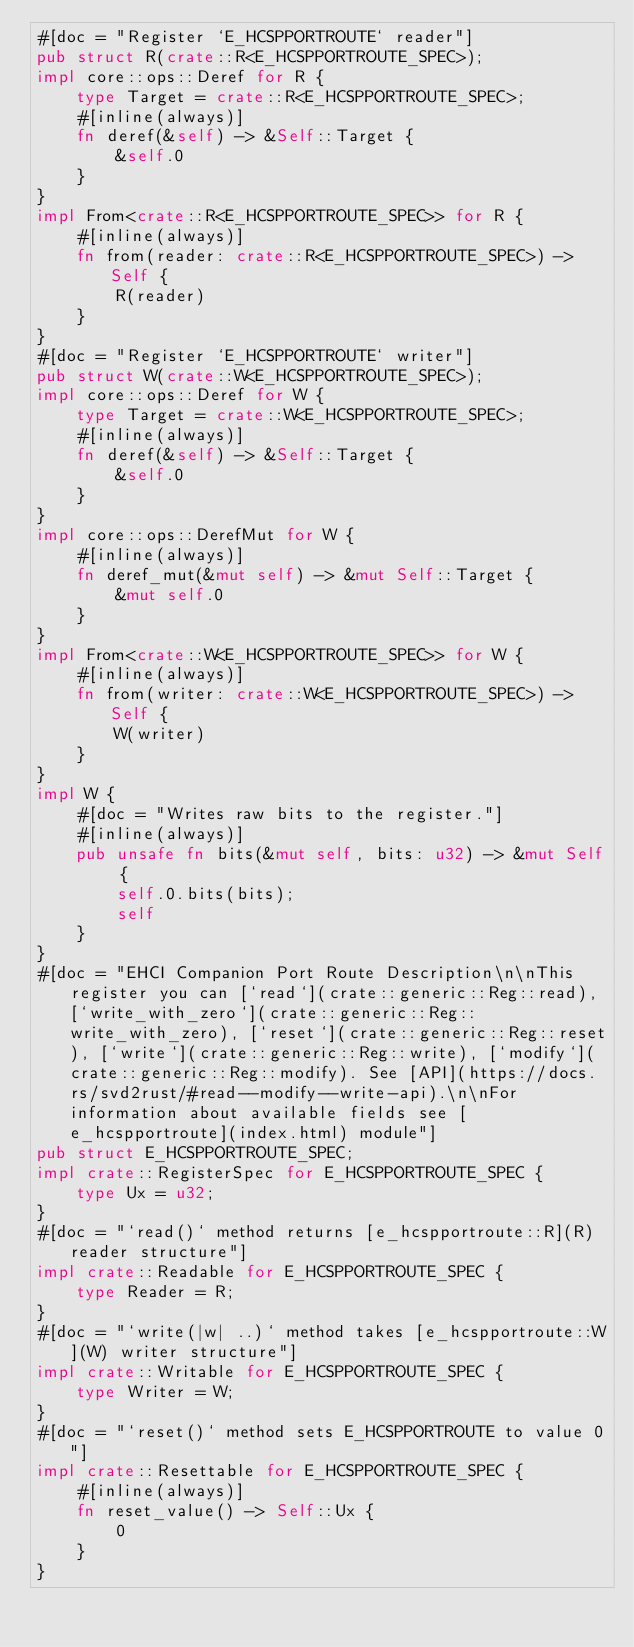<code> <loc_0><loc_0><loc_500><loc_500><_Rust_>#[doc = "Register `E_HCSPPORTROUTE` reader"]
pub struct R(crate::R<E_HCSPPORTROUTE_SPEC>);
impl core::ops::Deref for R {
    type Target = crate::R<E_HCSPPORTROUTE_SPEC>;
    #[inline(always)]
    fn deref(&self) -> &Self::Target {
        &self.0
    }
}
impl From<crate::R<E_HCSPPORTROUTE_SPEC>> for R {
    #[inline(always)]
    fn from(reader: crate::R<E_HCSPPORTROUTE_SPEC>) -> Self {
        R(reader)
    }
}
#[doc = "Register `E_HCSPPORTROUTE` writer"]
pub struct W(crate::W<E_HCSPPORTROUTE_SPEC>);
impl core::ops::Deref for W {
    type Target = crate::W<E_HCSPPORTROUTE_SPEC>;
    #[inline(always)]
    fn deref(&self) -> &Self::Target {
        &self.0
    }
}
impl core::ops::DerefMut for W {
    #[inline(always)]
    fn deref_mut(&mut self) -> &mut Self::Target {
        &mut self.0
    }
}
impl From<crate::W<E_HCSPPORTROUTE_SPEC>> for W {
    #[inline(always)]
    fn from(writer: crate::W<E_HCSPPORTROUTE_SPEC>) -> Self {
        W(writer)
    }
}
impl W {
    #[doc = "Writes raw bits to the register."]
    #[inline(always)]
    pub unsafe fn bits(&mut self, bits: u32) -> &mut Self {
        self.0.bits(bits);
        self
    }
}
#[doc = "EHCI Companion Port Route Description\n\nThis register you can [`read`](crate::generic::Reg::read), [`write_with_zero`](crate::generic::Reg::write_with_zero), [`reset`](crate::generic::Reg::reset), [`write`](crate::generic::Reg::write), [`modify`](crate::generic::Reg::modify). See [API](https://docs.rs/svd2rust/#read--modify--write-api).\n\nFor information about available fields see [e_hcspportroute](index.html) module"]
pub struct E_HCSPPORTROUTE_SPEC;
impl crate::RegisterSpec for E_HCSPPORTROUTE_SPEC {
    type Ux = u32;
}
#[doc = "`read()` method returns [e_hcspportroute::R](R) reader structure"]
impl crate::Readable for E_HCSPPORTROUTE_SPEC {
    type Reader = R;
}
#[doc = "`write(|w| ..)` method takes [e_hcspportroute::W](W) writer structure"]
impl crate::Writable for E_HCSPPORTROUTE_SPEC {
    type Writer = W;
}
#[doc = "`reset()` method sets E_HCSPPORTROUTE to value 0"]
impl crate::Resettable for E_HCSPPORTROUTE_SPEC {
    #[inline(always)]
    fn reset_value() -> Self::Ux {
        0
    }
}
</code> 